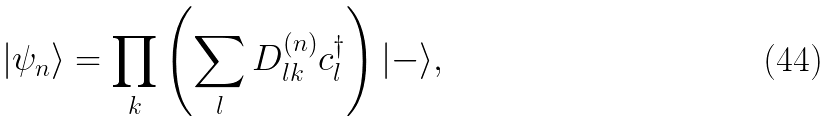Convert formula to latex. <formula><loc_0><loc_0><loc_500><loc_500>| \psi _ { n } \rangle = \prod _ { k } \left ( \sum _ { l } D ^ { ( n ) } _ { l k } c ^ { \dagger } _ { l } \right ) | - \rangle ,</formula> 